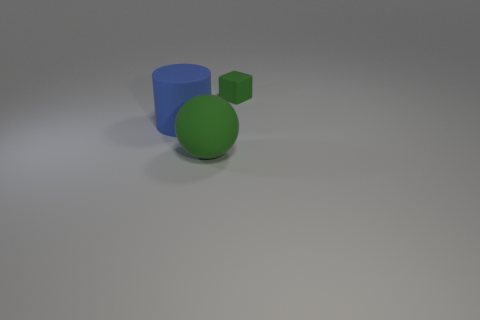There is a object that is the same color as the matte sphere; what is its material?
Your answer should be compact. Rubber. There is a big cylinder that is made of the same material as the green sphere; what is its color?
Give a very brief answer. Blue. Is there a blue rubber object of the same size as the cylinder?
Make the answer very short. No. Is the color of the large matte object that is left of the green matte sphere the same as the tiny thing?
Your response must be concise. No. The object that is left of the green cube and on the right side of the blue thing is what color?
Give a very brief answer. Green. What shape is the other object that is the same size as the blue thing?
Your response must be concise. Sphere. Is there a big blue rubber thing of the same shape as the large green rubber object?
Keep it short and to the point. No. There is a green rubber object in front of the matte cube; does it have the same size as the blue matte thing?
Ensure brevity in your answer.  Yes. There is a matte thing that is behind the large green sphere and in front of the green block; what size is it?
Keep it short and to the point. Large. How many other objects are the same material as the block?
Your answer should be compact. 2. 